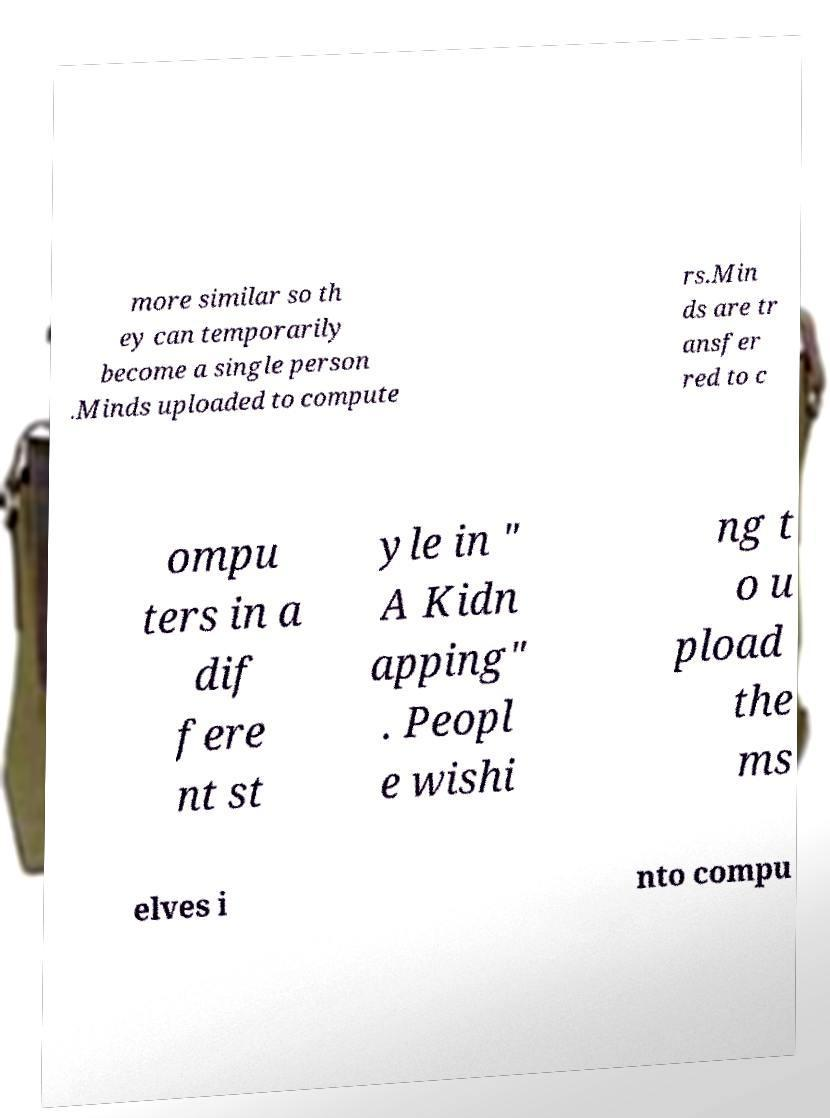Can you accurately transcribe the text from the provided image for me? more similar so th ey can temporarily become a single person .Minds uploaded to compute rs.Min ds are tr ansfer red to c ompu ters in a dif fere nt st yle in " A Kidn apping" . Peopl e wishi ng t o u pload the ms elves i nto compu 